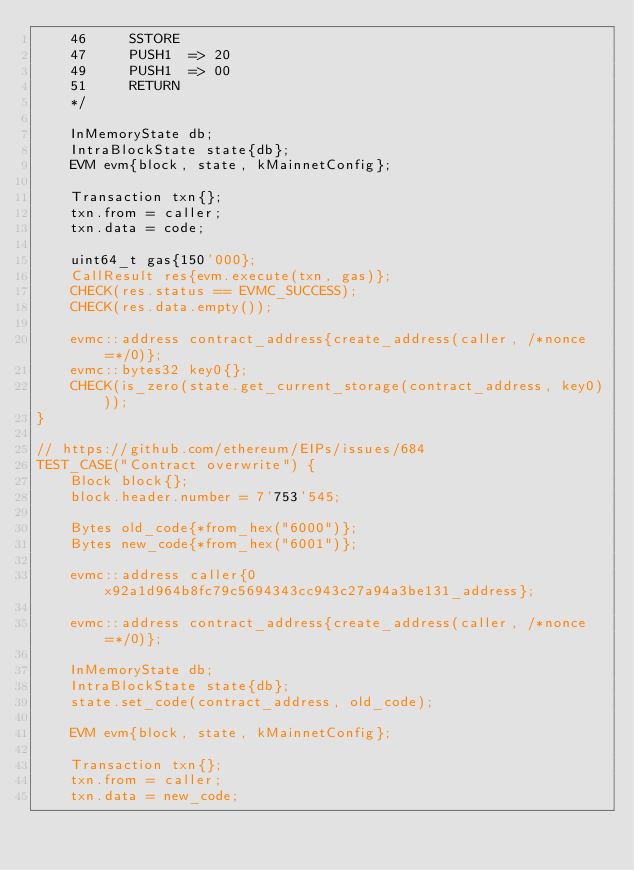Convert code to text. <code><loc_0><loc_0><loc_500><loc_500><_C++_>    46     SSTORE
    47     PUSH1  => 20
    49     PUSH1  => 00
    51     RETURN
    */

    InMemoryState db;
    IntraBlockState state{db};
    EVM evm{block, state, kMainnetConfig};

    Transaction txn{};
    txn.from = caller;
    txn.data = code;

    uint64_t gas{150'000};
    CallResult res{evm.execute(txn, gas)};
    CHECK(res.status == EVMC_SUCCESS);
    CHECK(res.data.empty());

    evmc::address contract_address{create_address(caller, /*nonce=*/0)};
    evmc::bytes32 key0{};
    CHECK(is_zero(state.get_current_storage(contract_address, key0)));
}

// https://github.com/ethereum/EIPs/issues/684
TEST_CASE("Contract overwrite") {
    Block block{};
    block.header.number = 7'753'545;

    Bytes old_code{*from_hex("6000")};
    Bytes new_code{*from_hex("6001")};

    evmc::address caller{0x92a1d964b8fc79c5694343cc943c27a94a3be131_address};

    evmc::address contract_address{create_address(caller, /*nonce=*/0)};

    InMemoryState db;
    IntraBlockState state{db};
    state.set_code(contract_address, old_code);

    EVM evm{block, state, kMainnetConfig};

    Transaction txn{};
    txn.from = caller;
    txn.data = new_code;
</code> 